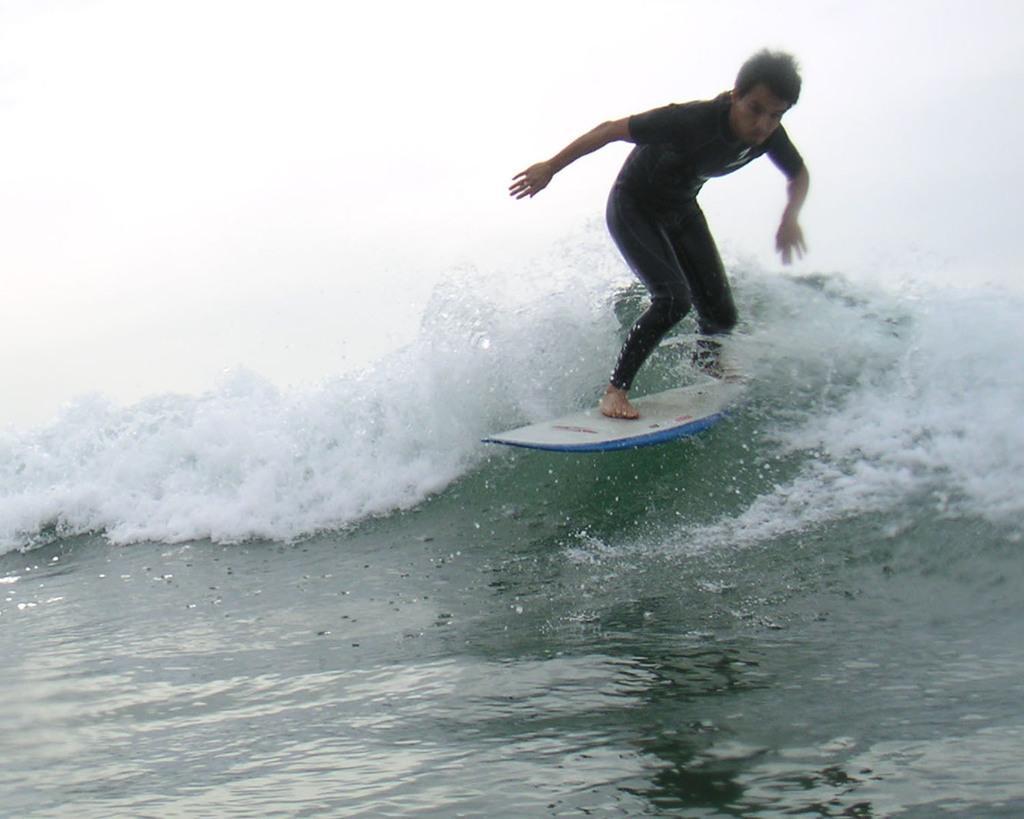Can you describe this image briefly? This image is taken outdoors. At the bottom of the image there is a sea with waves. In the middle of the image a man is surfing on the sea with a surfing board. 